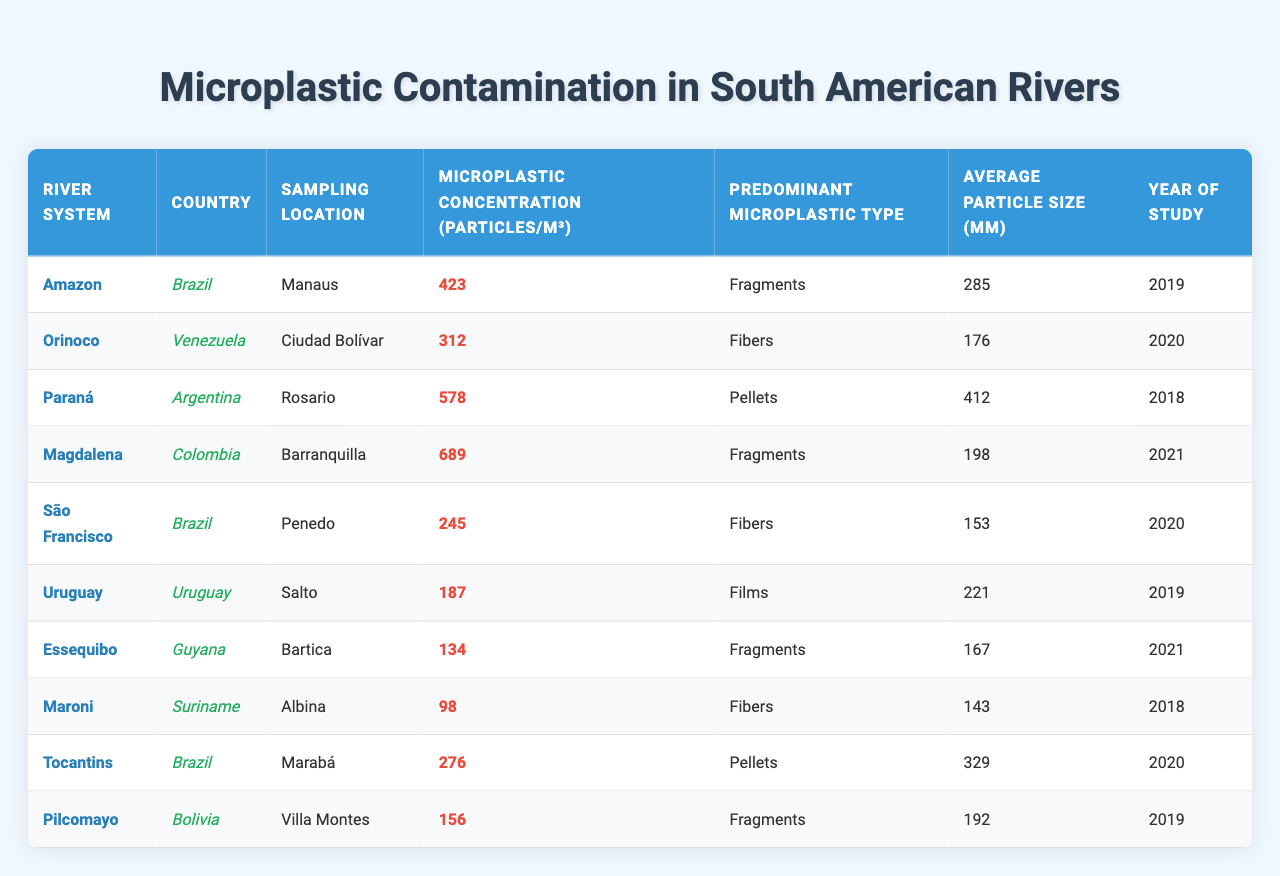What is the microplastic concentration in the Magdalena river system? The table indicates that the microplastic concentration in the Magdalena river system is 689 particles/m³.
Answer: 689 particles/m³ Which country has the highest microplastic concentration recorded in the table? By reviewing the concentrations in each river system, the Magdalena river system in Colombia has the highest concentration at 689 particles/m³.
Answer: Colombia What are the predominant microplastic types found in the Essequibo and Maroni river systems? The table shows that the Essequibo river system has "Fragments" as the predominant type, while the Maroni system has "Fibers".
Answer: Essequibo: Fragments, Maroni: Fibers Calculate the average microplastic concentration across all river systems listed in the table. The concentrations are 423, 312, 578, 689, 245, 187, 134, 98, 276, and 156. Adding them gives a total of 2998, and there are 10 river systems, so 2998/10 = 299.8.
Answer: 299.8 particles/m³ Is the average particle size in the Amazon river system greater than that in the São Francisco river system? The average particle size in the Amazon is 285 μm and in the São Francisco is 153 μm. Since 285 is greater than 153, the statement is true.
Answer: Yes Which river system has the smallest average particle size, and what is that size? The Maroni river system has the smallest average particle size at 143 μm, which can be seen from the table data.
Answer: Maroni: 143 μm How many river systems have microplastic concentrations above 300 particles/m³? By reviewing the concentrations, the rivers that exceed 300 are Amazon, Orinoco, Paraná, Magdalena, and Tocantins. That totals to 5 river systems.
Answer: 5 river systems Is there a correlation between the predominant microplastic type and the average particle size in the river systems? To assess the correlation, we see that "Pellets" in Paraná has the largest size (412 μm), while "Fibers" in Maroni is the smallest (143 μm). This suggests that sizes vary without a consistent trend based on type alone.
Answer: No clear correlation 